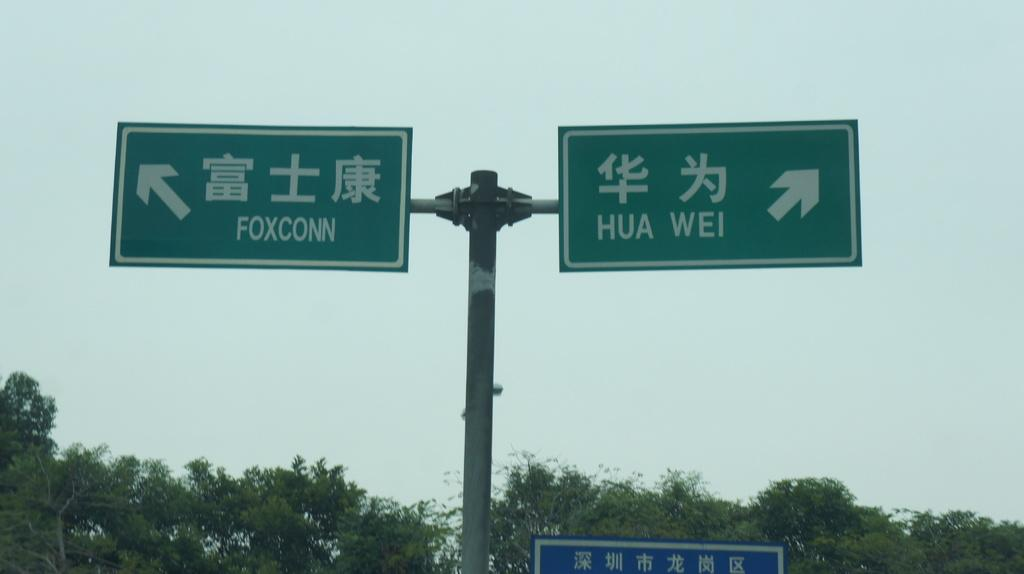<image>
Provide a brief description of the given image. Two green signs pointing to Foxconn on the left and Hua Wei on the right 